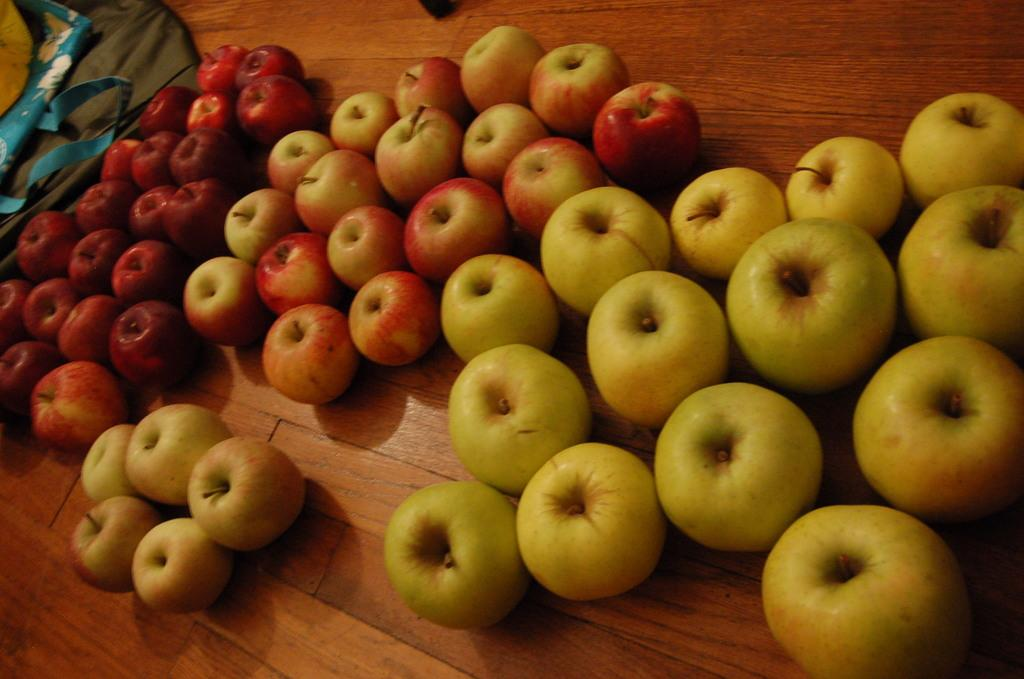What type of fruit is present in the image? There are apples in the image. Can you describe the apples in the image? The apples are in different colors. What surface are the apples resting on? The apples are on a wooden surface. What type of work is being done on the apples in the image? There is no indication of any work being done on the apples in the image; they are simply resting on a wooden surface. 